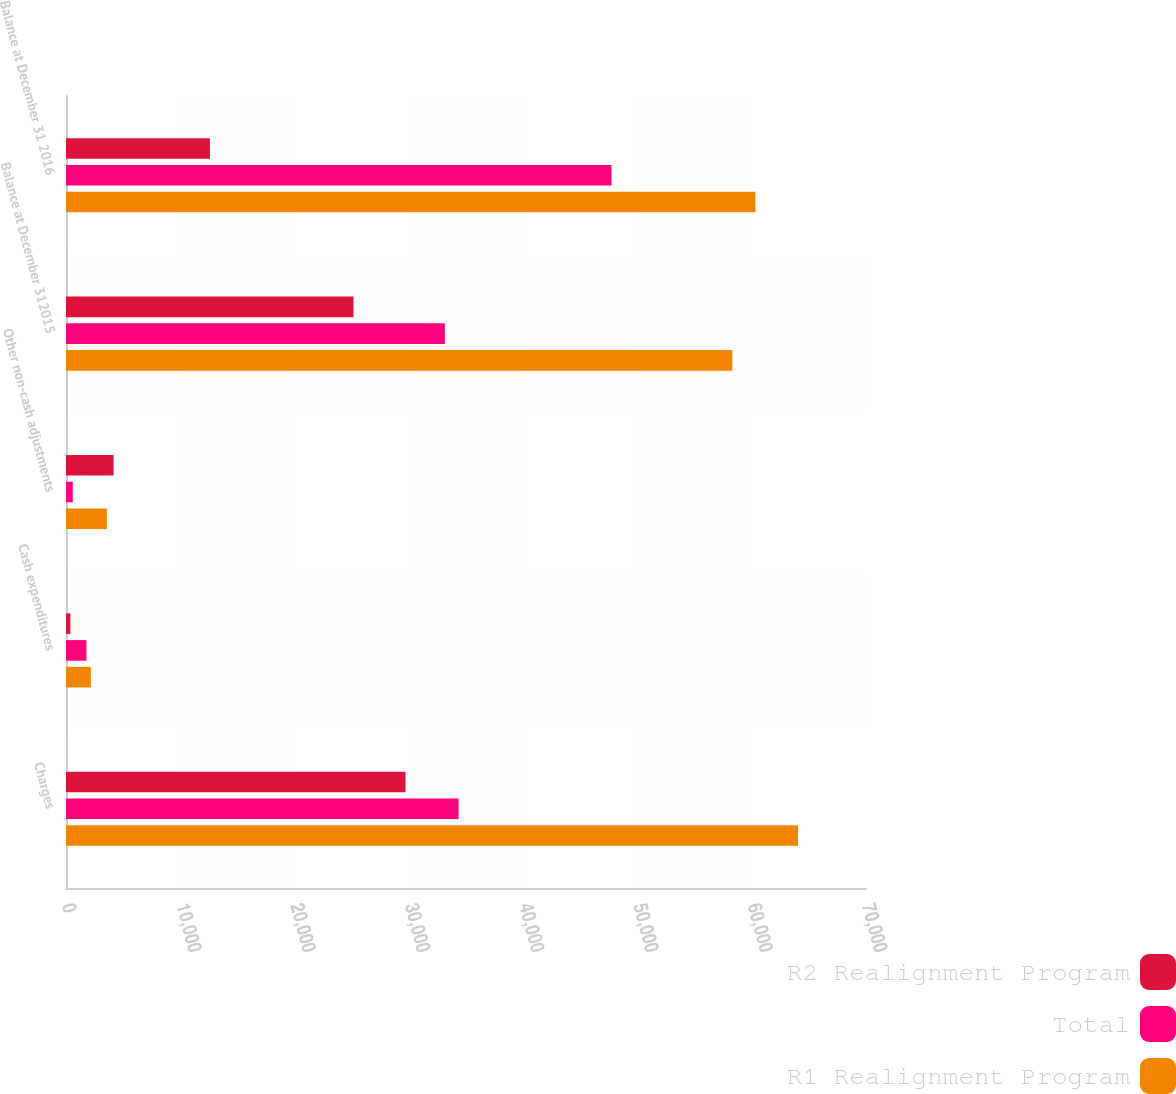<chart> <loc_0><loc_0><loc_500><loc_500><stacked_bar_chart><ecel><fcel>Charges<fcel>Cash expenditures<fcel>Other non-cash adjustments<fcel>Balance at December 312015<fcel>Balance at December 31 2016<nl><fcel>R2 Realignment Program<fcel>29705<fcel>383<fcel>4166<fcel>25156<fcel>12594<nl><fcel>Total<fcel>34350<fcel>1791<fcel>589<fcel>33148<fcel>47733<nl><fcel>R1 Realignment Program<fcel>64055<fcel>2174<fcel>3577<fcel>58304<fcel>60327<nl></chart> 